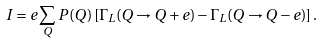Convert formula to latex. <formula><loc_0><loc_0><loc_500><loc_500>I = e \sum _ { Q } P ( Q ) \left [ \Gamma _ { L } ( Q \rightarrow Q + e ) - \Gamma _ { L } ( Q \rightarrow Q - e ) \right ] .</formula> 